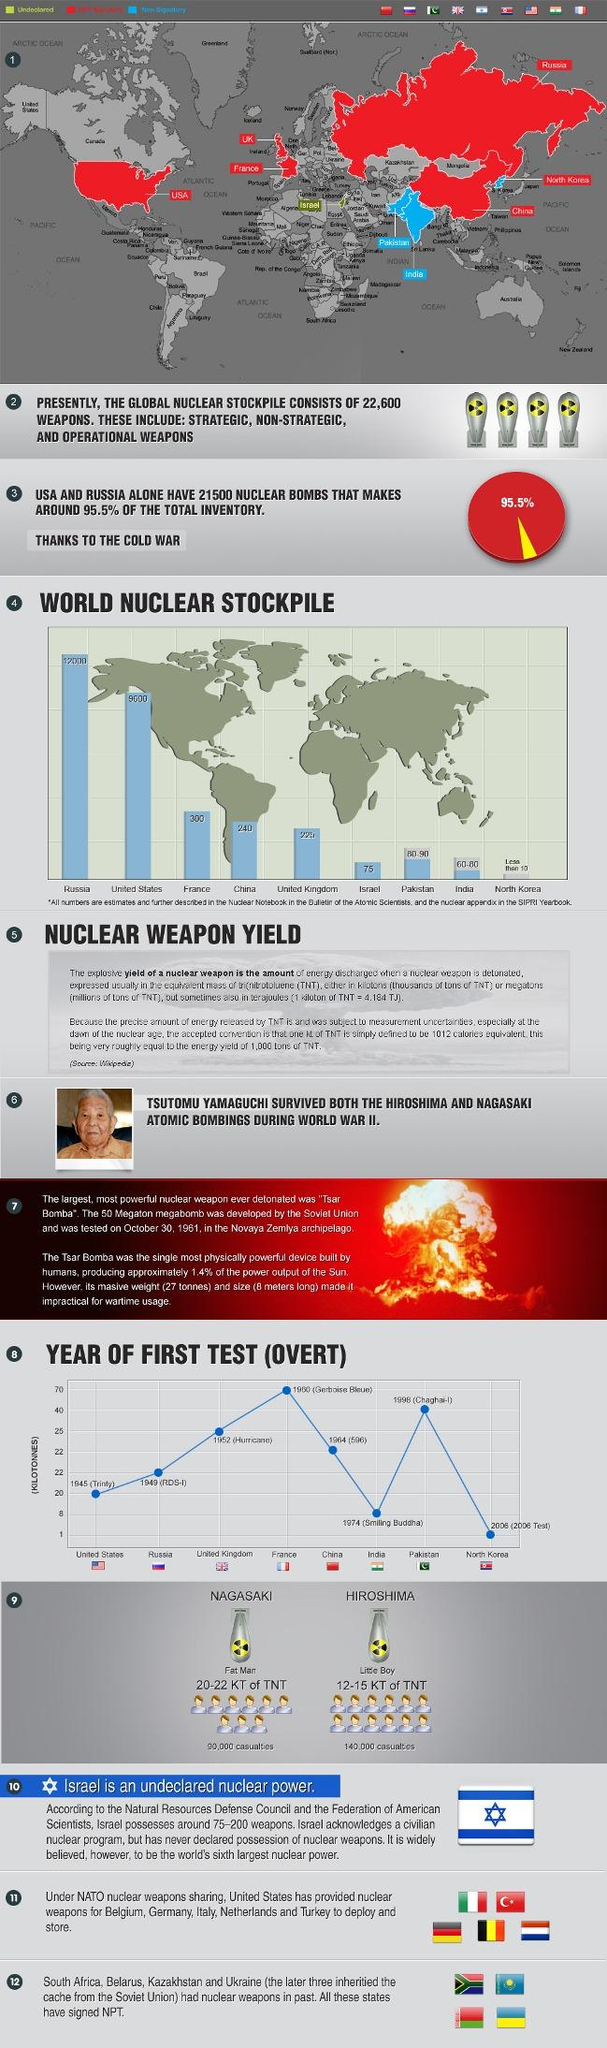Mention a couple of crucial points in this snapshot. Russia has more nuclear weapons than the United States. Hurricane was the first nuclear test conducted by the United Kingdom, which took place in 1952. Tsar Bomba, the largest nuclear weapon ever detonated, had a yield of approximately 50 megatons and a length of 8 meters. The first nuclear test conducted by the US was Trinity, which was carried out in 1945. The casualties in Nagasaki were estimated to be 90,000. 